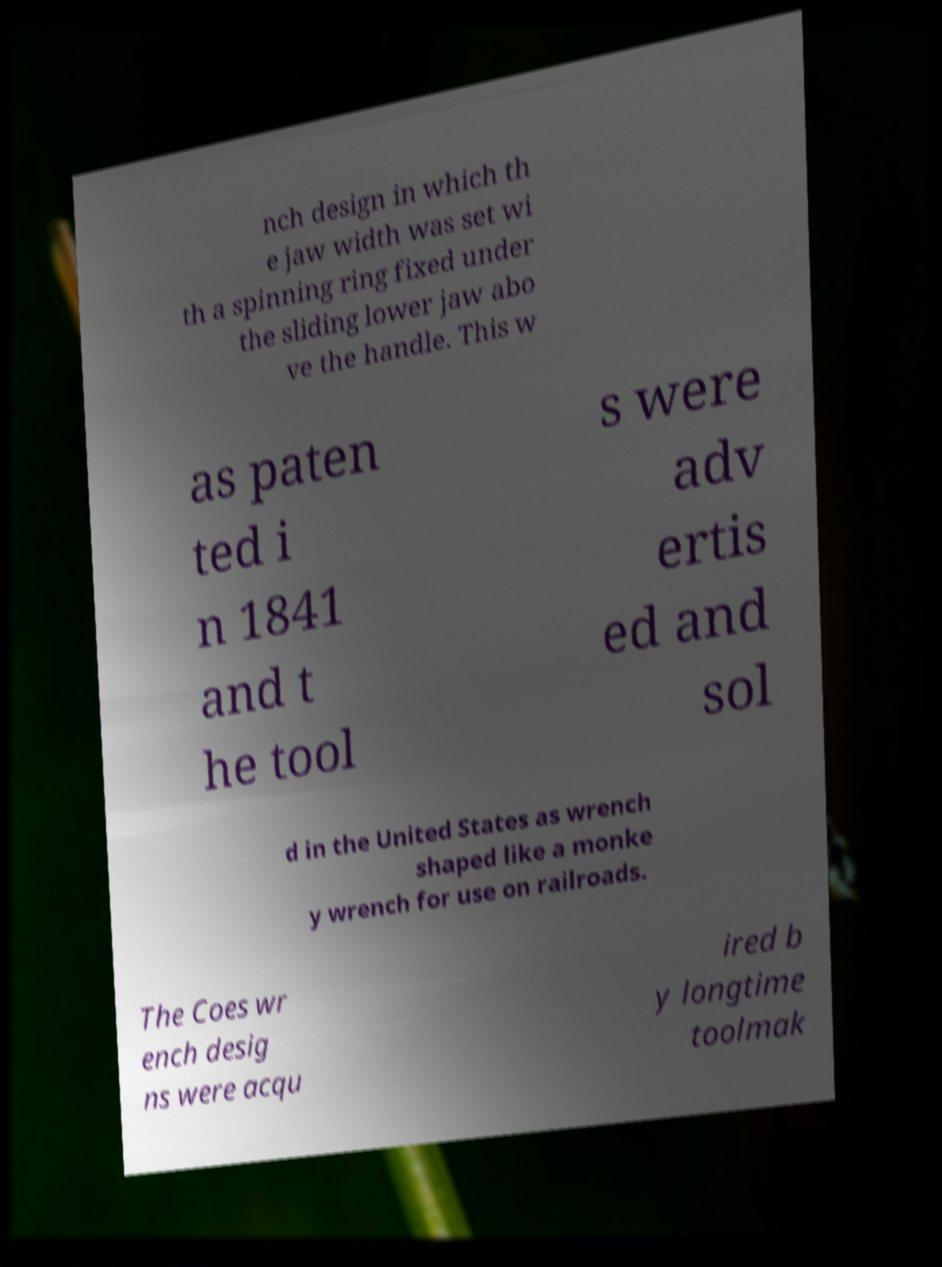I need the written content from this picture converted into text. Can you do that? nch design in which th e jaw width was set wi th a spinning ring fixed under the sliding lower jaw abo ve the handle. This w as paten ted i n 1841 and t he tool s were adv ertis ed and sol d in the United States as wrench shaped like a monke y wrench for use on railroads. The Coes wr ench desig ns were acqu ired b y longtime toolmak 